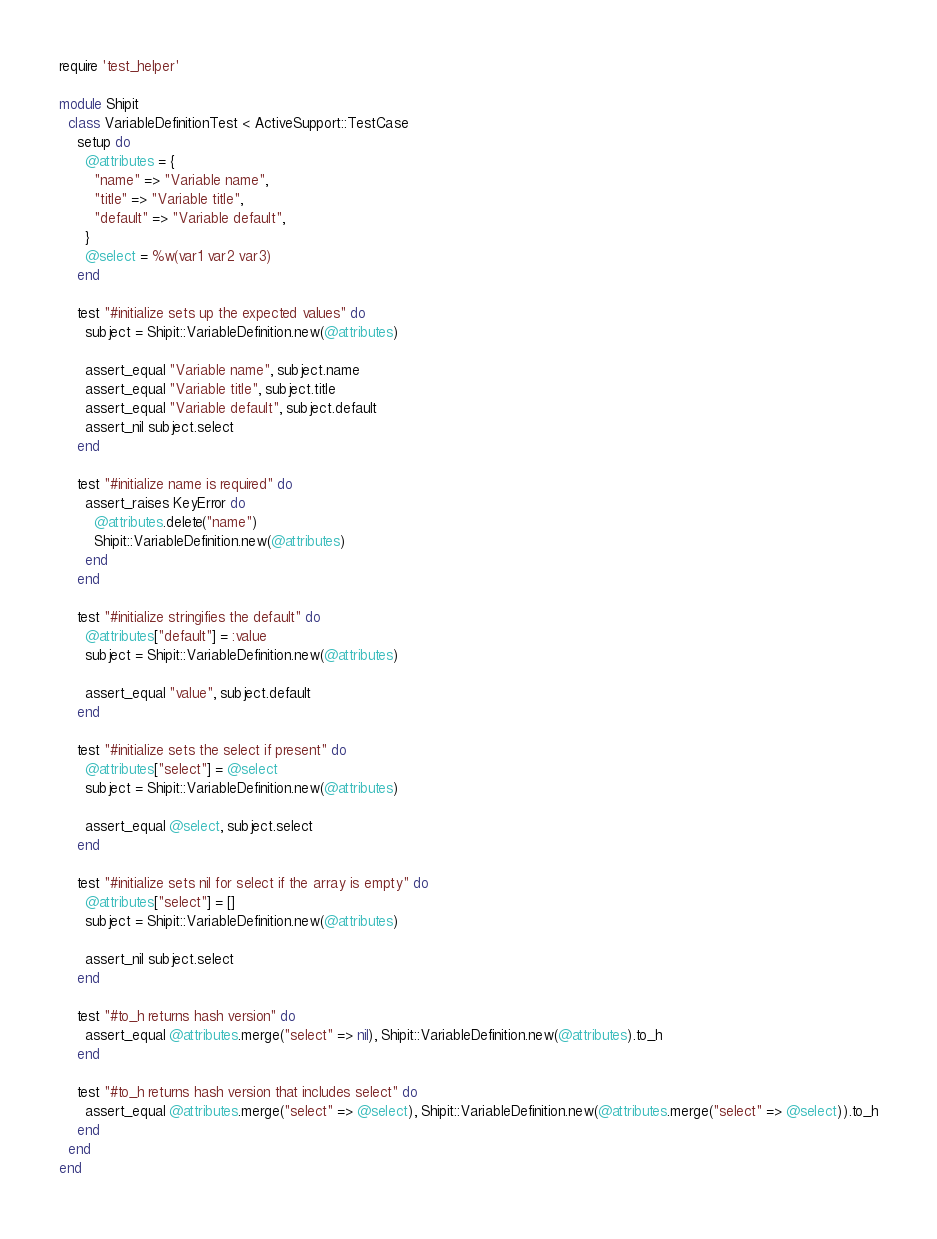Convert code to text. <code><loc_0><loc_0><loc_500><loc_500><_Ruby_>require 'test_helper'

module Shipit
  class VariableDefinitionTest < ActiveSupport::TestCase
    setup do
      @attributes = {
        "name" => "Variable name",
        "title" => "Variable title",
        "default" => "Variable default",
      }
      @select = %w(var1 var2 var3)
    end

    test "#initialize sets up the expected values" do
      subject = Shipit::VariableDefinition.new(@attributes)

      assert_equal "Variable name", subject.name
      assert_equal "Variable title", subject.title
      assert_equal "Variable default", subject.default
      assert_nil subject.select
    end

    test "#initialize name is required" do
      assert_raises KeyError do
        @attributes.delete("name")
        Shipit::VariableDefinition.new(@attributes)
      end
    end

    test "#initialize stringifies the default" do
      @attributes["default"] = :value
      subject = Shipit::VariableDefinition.new(@attributes)

      assert_equal "value", subject.default
    end

    test "#initialize sets the select if present" do
      @attributes["select"] = @select
      subject = Shipit::VariableDefinition.new(@attributes)

      assert_equal @select, subject.select
    end

    test "#initialize sets nil for select if the array is empty" do
      @attributes["select"] = []
      subject = Shipit::VariableDefinition.new(@attributes)

      assert_nil subject.select
    end

    test "#to_h returns hash version" do
      assert_equal @attributes.merge("select" => nil), Shipit::VariableDefinition.new(@attributes).to_h
    end

    test "#to_h returns hash version that includes select" do
      assert_equal @attributes.merge("select" => @select), Shipit::VariableDefinition.new(@attributes.merge("select" => @select)).to_h
    end
  end
end
</code> 